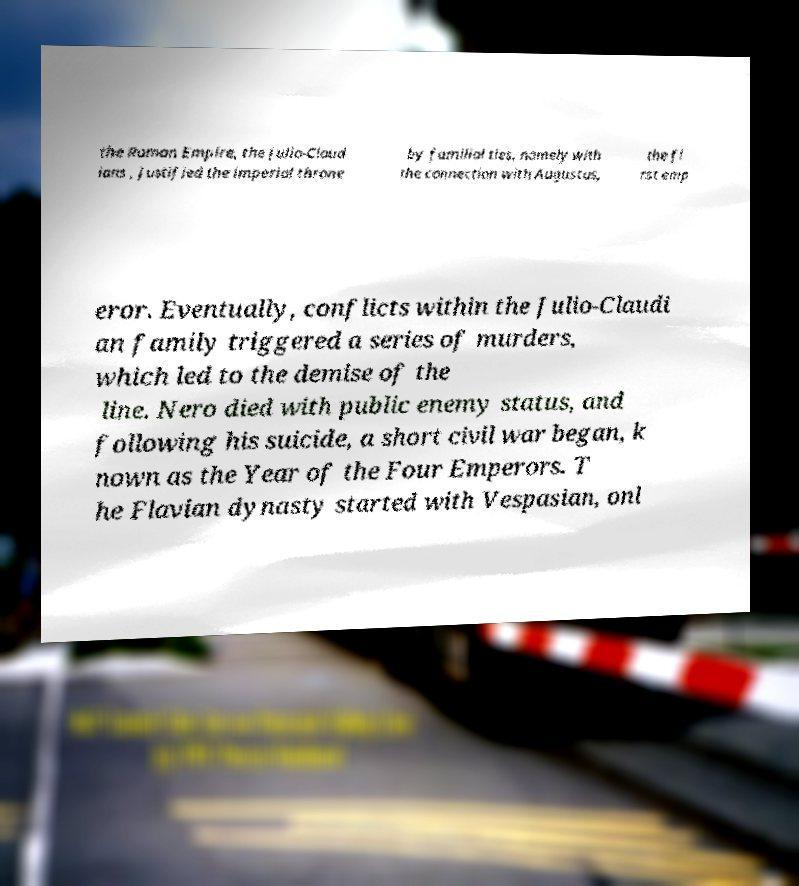I need the written content from this picture converted into text. Can you do that? the Roman Empire, the Julio-Claud ians , justified the imperial throne by familial ties, namely with the connection with Augustus, the fi rst emp eror. Eventually, conflicts within the Julio-Claudi an family triggered a series of murders, which led to the demise of the line. Nero died with public enemy status, and following his suicide, a short civil war began, k nown as the Year of the Four Emperors. T he Flavian dynasty started with Vespasian, onl 